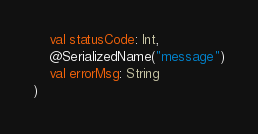<code> <loc_0><loc_0><loc_500><loc_500><_Kotlin_>    val statusCode: Int,
    @SerializedName("message")
    val errorMsg: String
)
</code> 